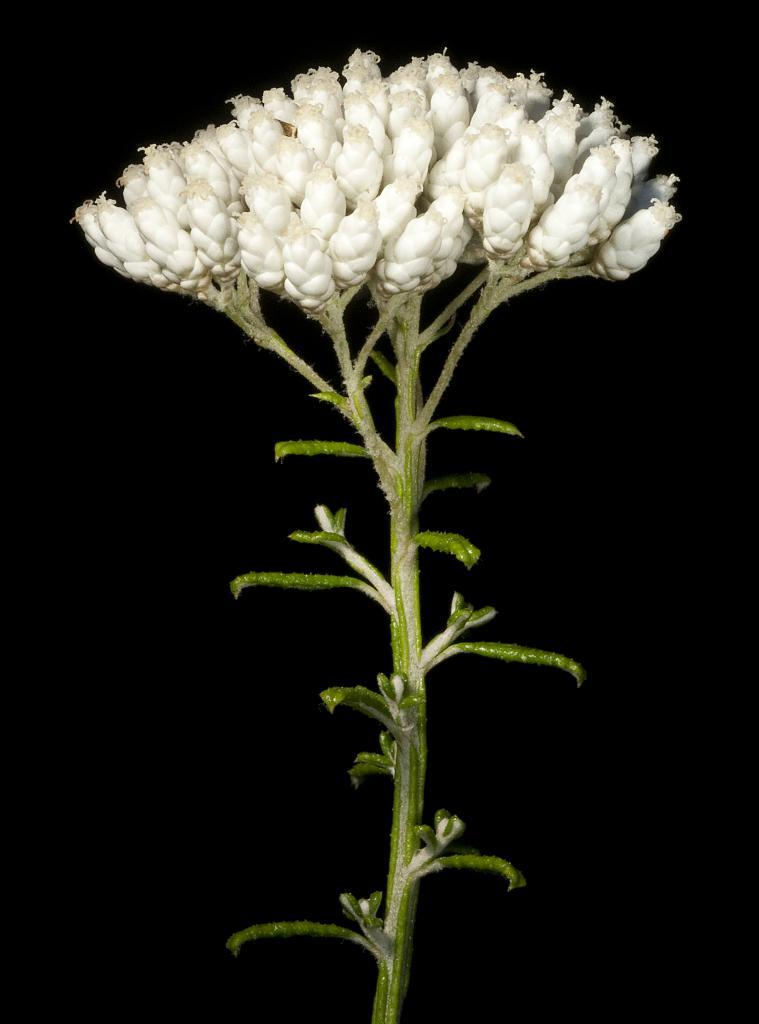What is the main subject of the image? The main subject of the image is a plant with many buds. What can be observed about the background of the image? The background of the image is dark. What type of regret can be seen on the plant in the image? There is no regret present in the image; it features a plant with many buds. How does the quiet cub affect the plant in the image? There is no quiet cub present in the image, so it cannot affect the plant. 